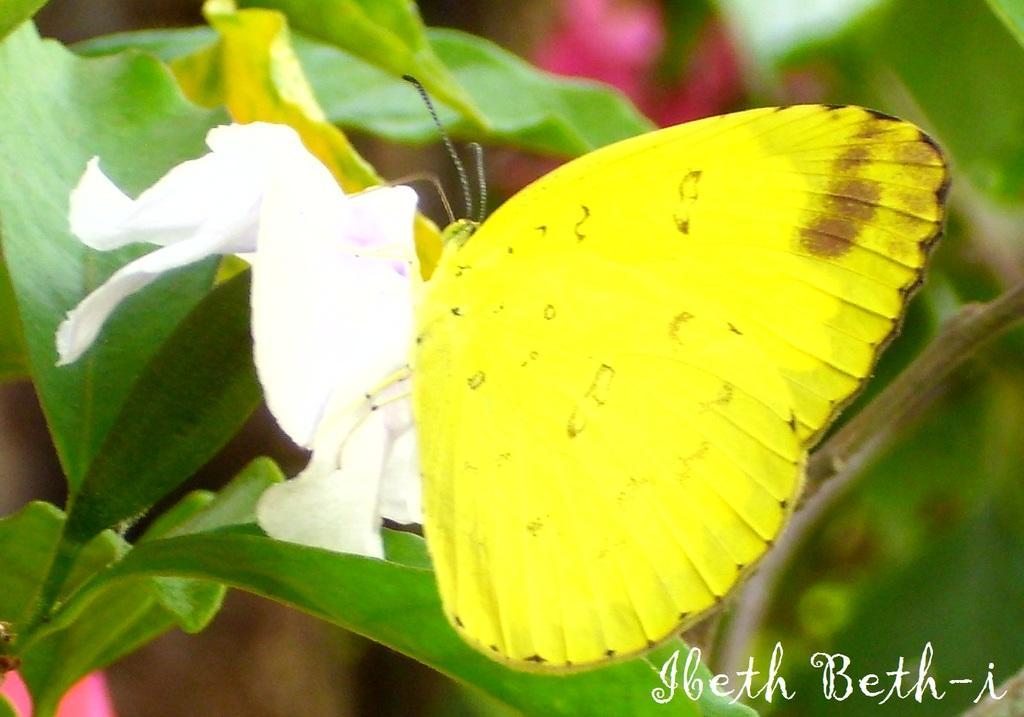How would you summarize this image in a sentence or two? In this picture I can observe butterfly which is in yellow color. On the left side I can observe white color flower and a plant. On the bottom right side I can observe text. 